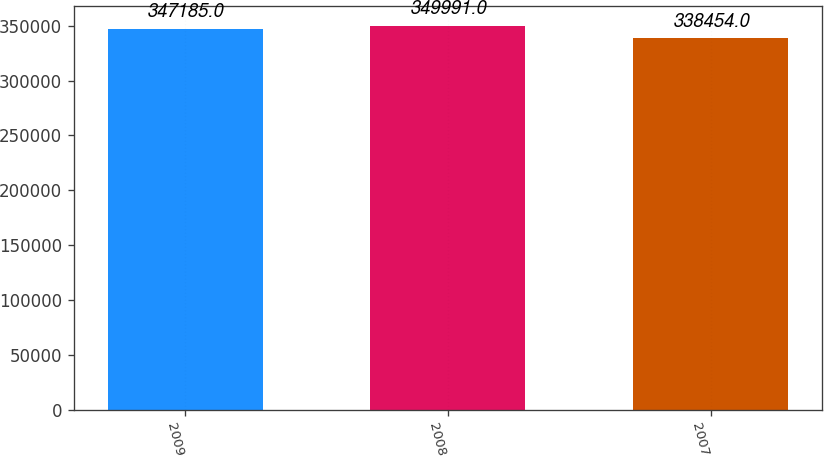<chart> <loc_0><loc_0><loc_500><loc_500><bar_chart><fcel>2009<fcel>2008<fcel>2007<nl><fcel>347185<fcel>349991<fcel>338454<nl></chart> 